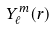<formula> <loc_0><loc_0><loc_500><loc_500>Y _ { \ell } ^ { m } ( { r } )</formula> 